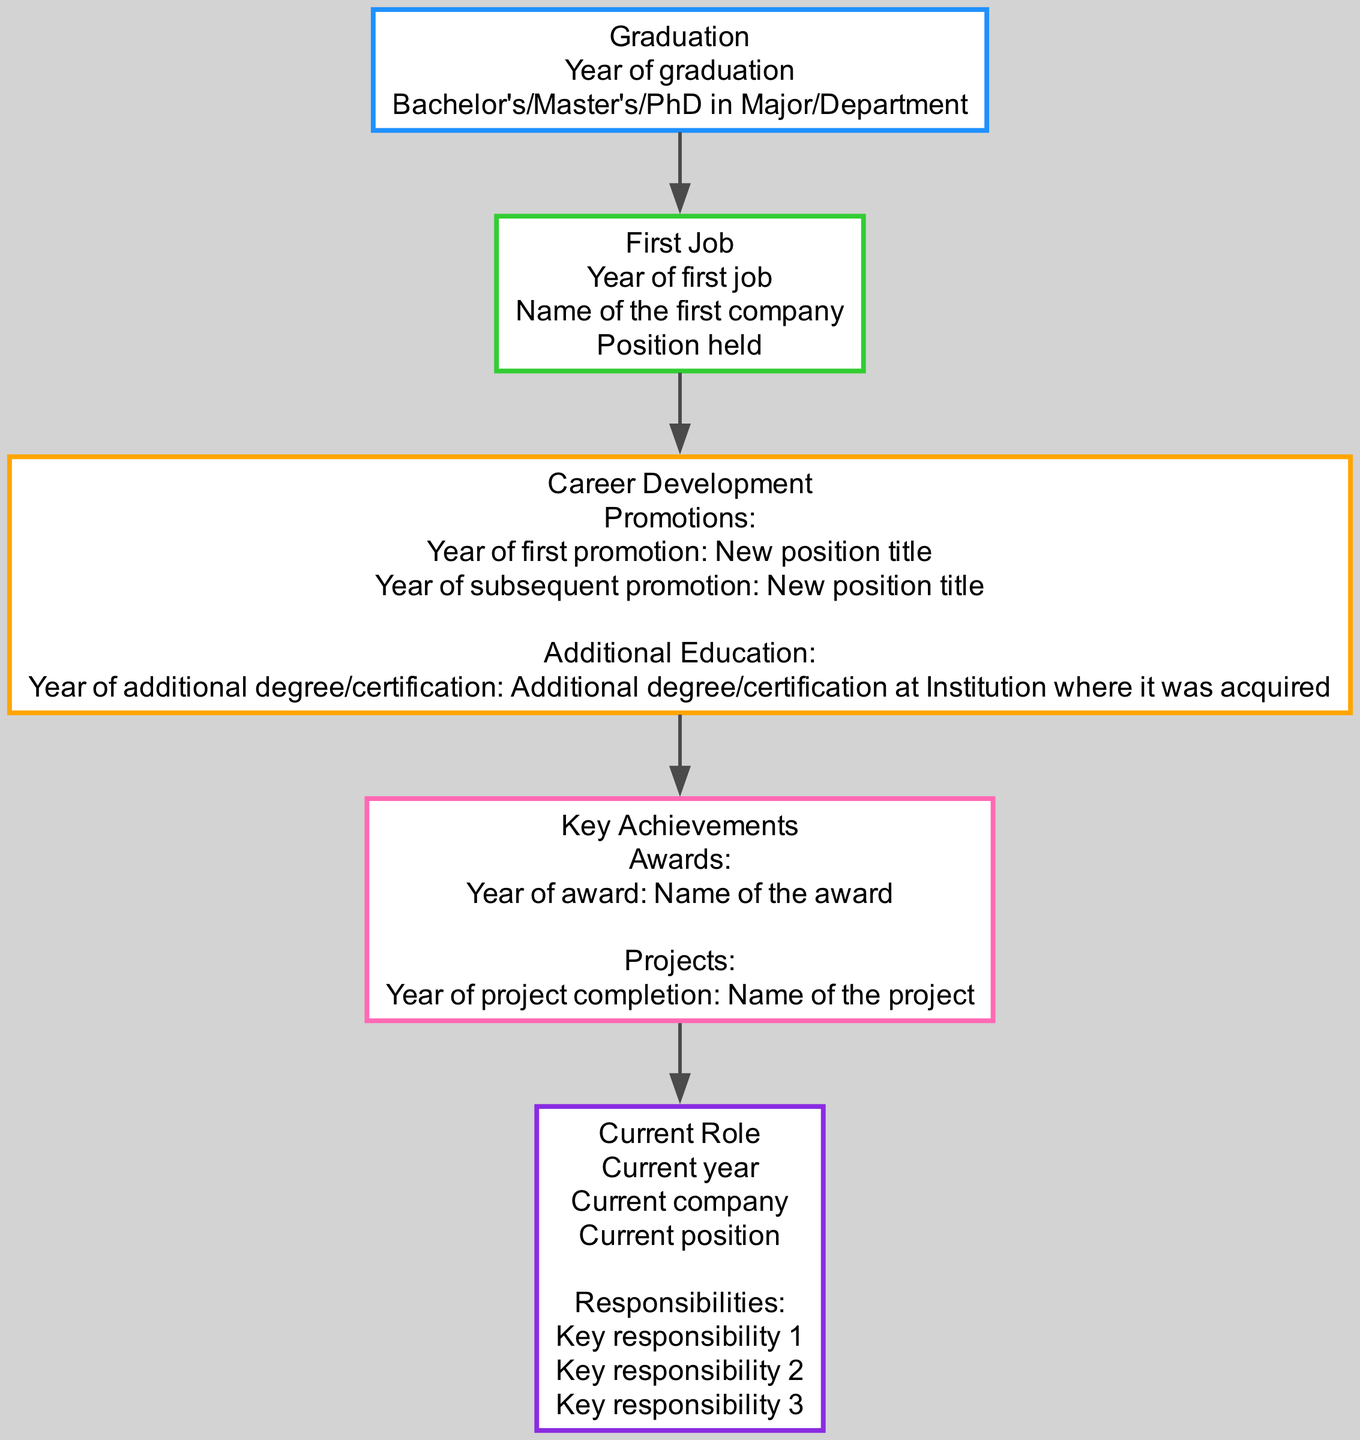What is the first milestone in the career path? The first milestone according to the diagram is "Graduation." This is the initial stage before starting a career and is depicted as the starting point of the career path.
Answer: Graduation Which degree is mentioned at the graduation stage? The degree at the graduation stage is "Bachelor's/Master's/PhD." This represents the educational attainment level achieved by the alumni.
Answer: Bachelor's/Master's/PhD What does the first job node indicate? The first job node indicates the "Year of first job," "Name of the first company," and "Position held." This information specifies the alumni's first employment experience.
Answer: Year of first job, Name of the first company, Position held How many promotions are mentioned in the career development stage? There are two promotions mentioned in the career development stage. Each promotion is detailed with a year and a new position title, showing the alumni's career progression.
Answer: 2 What is the color of the key achievements stage? The color assigned to the key achievements stage is "pink" (specifically #ff69b4 in hexadecimal). This color visually distinguishes the key achievements from other stages.
Answer: pink Which professional responsibilities are listed under the current role? The current role includes three responsibilities that are explicitly mentioned in the diagram, showcasing the main duties of the alumni in their current position.
Answer: Key responsibility 1, Key responsibility 2, Key responsibility 3 In what stage do alumni receive awards? Alumni receive awards in the "Key Achievements" stage. This stage highlights significant recognitions the alumni have received throughout their career.
Answer: Key Achievements What does the arrow between graduation and the first job represent? The arrow between graduation and the first job represents the progression from education to employment. It shows the transition that alumni make after completing their degree.
Answer: Progression from education to employment How does the career development stage connect to key achievements? The career development stage connects to key achievements through an edge that indicates the flow in the career path, signifying that career growth can lead to notable achievements.
Answer: Edge indicating flow from career development to key achievements 